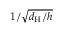<formula> <loc_0><loc_0><loc_500><loc_500>1 / \sqrt { d _ { H } / h }</formula> 